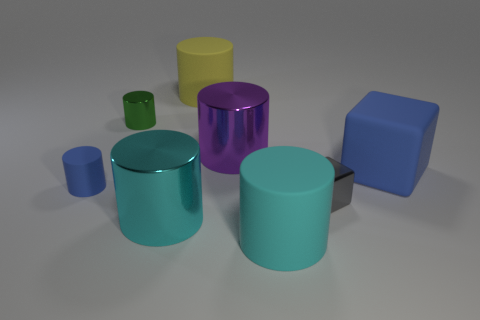How does the presence of multiple colors affect the composition of the image? The variety of colors in the image creates a vibrant and dynamic composition. Each color brings its own emotion and energy, which when combined, can evoke a joyful or playful atmosphere. The colors also help to distinguish the individual shapes, making it easier to observe the details and relationships among the objects. 